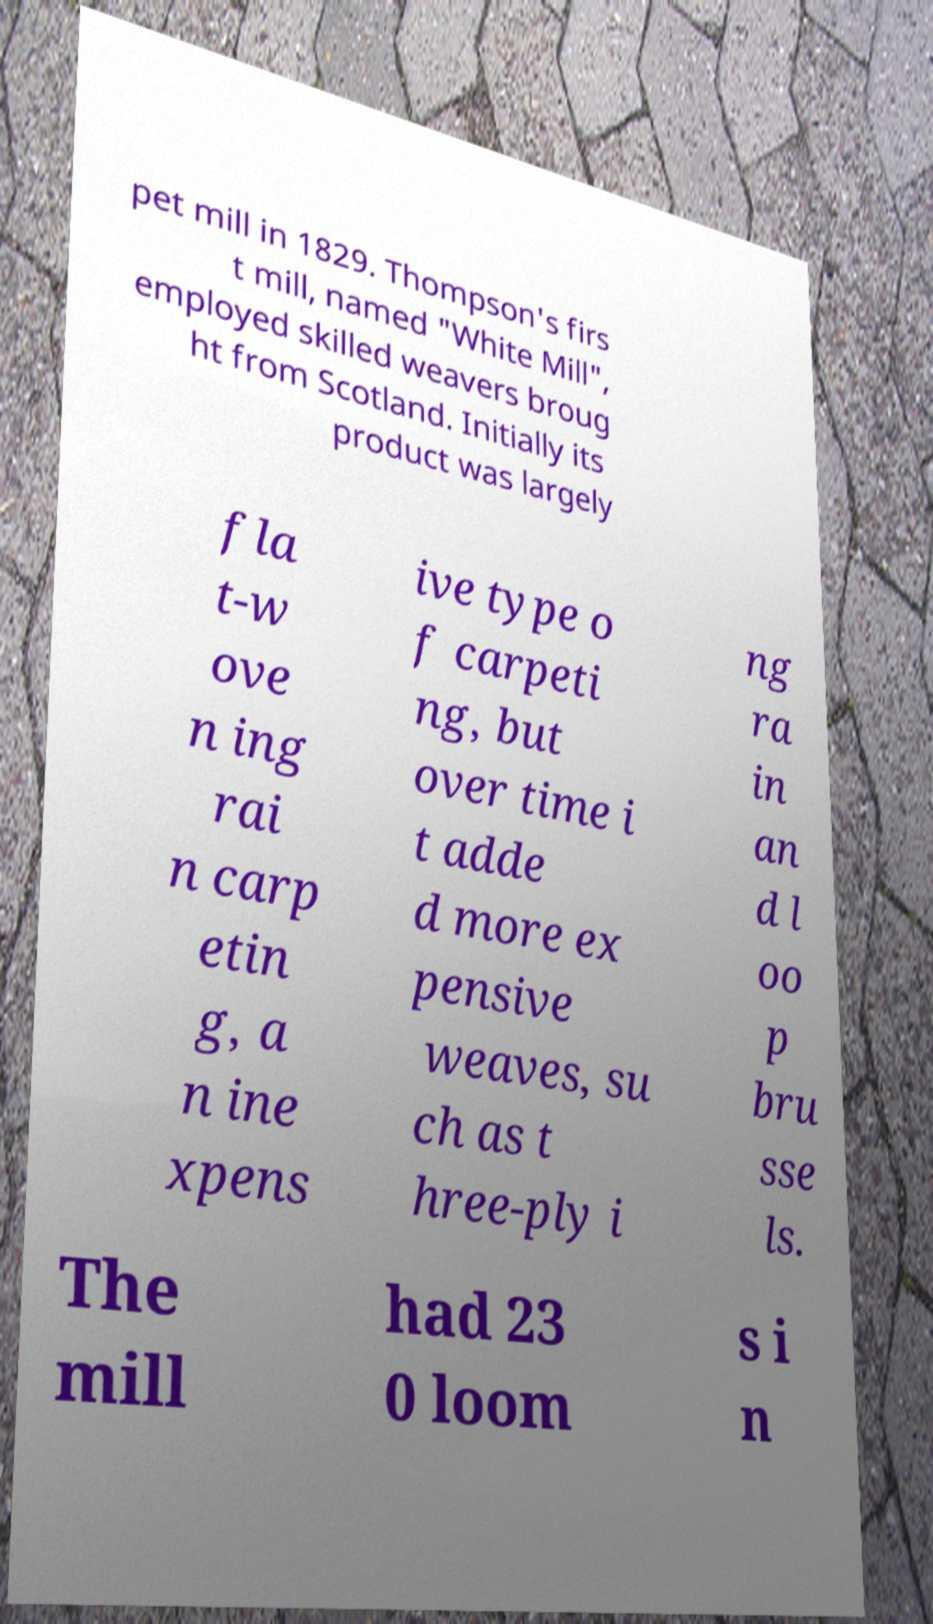There's text embedded in this image that I need extracted. Can you transcribe it verbatim? pet mill in 1829. Thompson's firs t mill, named "White Mill", employed skilled weavers broug ht from Scotland. Initially its product was largely fla t-w ove n ing rai n carp etin g, a n ine xpens ive type o f carpeti ng, but over time i t adde d more ex pensive weaves, su ch as t hree-ply i ng ra in an d l oo p bru sse ls. The mill had 23 0 loom s i n 